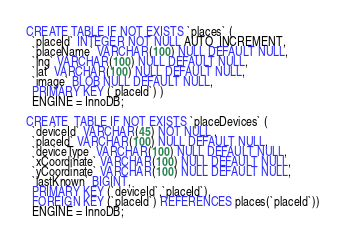Convert code to text. <code><loc_0><loc_0><loc_500><loc_500><_SQL_>CREATE TABLE IF NOT EXISTS `places` (
  `placeId` INTEGER NOT NULL AUTO_INCREMENT,
  `placeName` VARCHAR(100) NULL DEFAULT NULL,
  `lng` VARCHAR(100) NULL DEFAULT NULL,
  `lat` VARCHAR(100) NULL DEFAULT NULL,
  `image` BLOB NULL DEFAULT NULL,
  PRIMARY KEY (`placeId`) )
  ENGINE = InnoDB;

CREATE  TABLE IF NOT EXISTS `placeDevices` (
  `deviceId` VARCHAR(45) NOT NULL ,
  `placeId` VARCHAR(100) NULL DEFAULT NULL,
  `deviceType` VARCHAR(100) NULL DEFAULT NULL,
  `xCoordinate` VARCHAR(100) NULL DEFAULT NULL,
  `yCoordinate` VARCHAR(100) NULL DEFAULT NULL,
  `lastKnown` BIGINT,
  PRIMARY KEY (`deviceId`,`placeId`),
  FOREIGN KEY (`placeId`) REFERENCES places(`placeId`))
  ENGINE = InnoDB;




</code> 